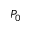Convert formula to latex. <formula><loc_0><loc_0><loc_500><loc_500>P _ { 0 }</formula> 